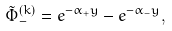<formula> <loc_0><loc_0><loc_500><loc_500>\tilde { \Phi } ^ { ( k ) } _ { - } = e ^ { - \alpha _ { + } y } - e ^ { - \alpha _ { - } y } ,</formula> 